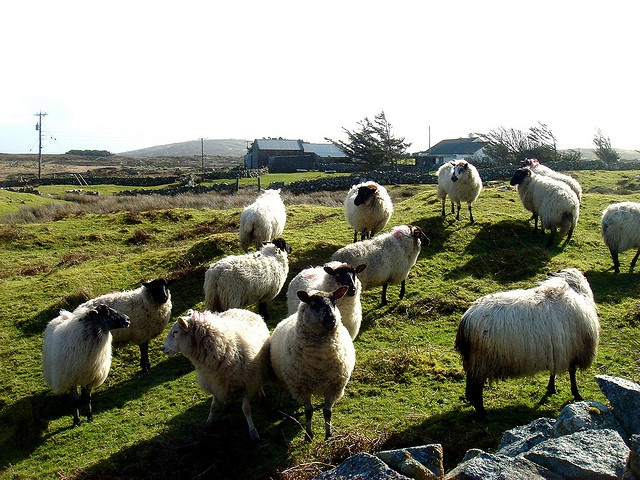Describe the objects in this image and their specific colors. I can see sheep in white, black, gray, ivory, and darkgreen tones, sheep in white, black, ivory, gray, and darkgreen tones, sheep in white, black, ivory, gray, and darkgreen tones, sheep in white, black, gray, darkgreen, and ivory tones, and sheep in white, black, gray, ivory, and darkgreen tones in this image. 